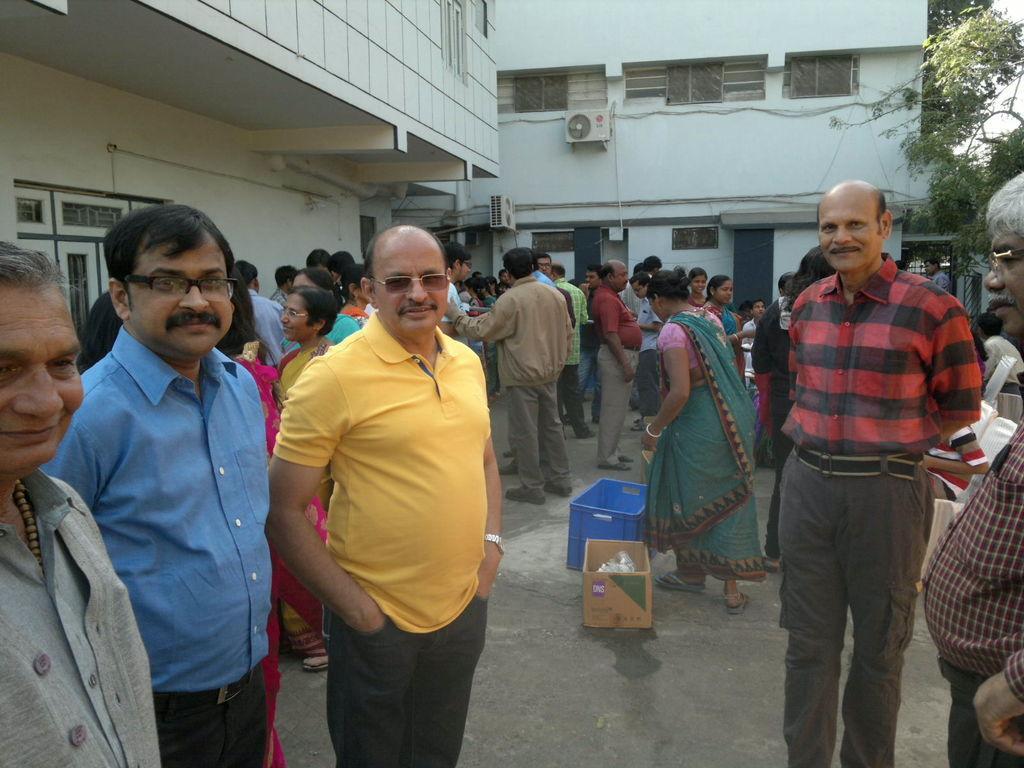Could you give a brief overview of what you see in this image? In this image there are group of people standing on the floor. On the right side top there is a tree. In the background there are buildings. At the bottom there is a cardboard box on the floor. Beside it there is a tray. In the middle we can see there is an air conditioner attached to the wall. 